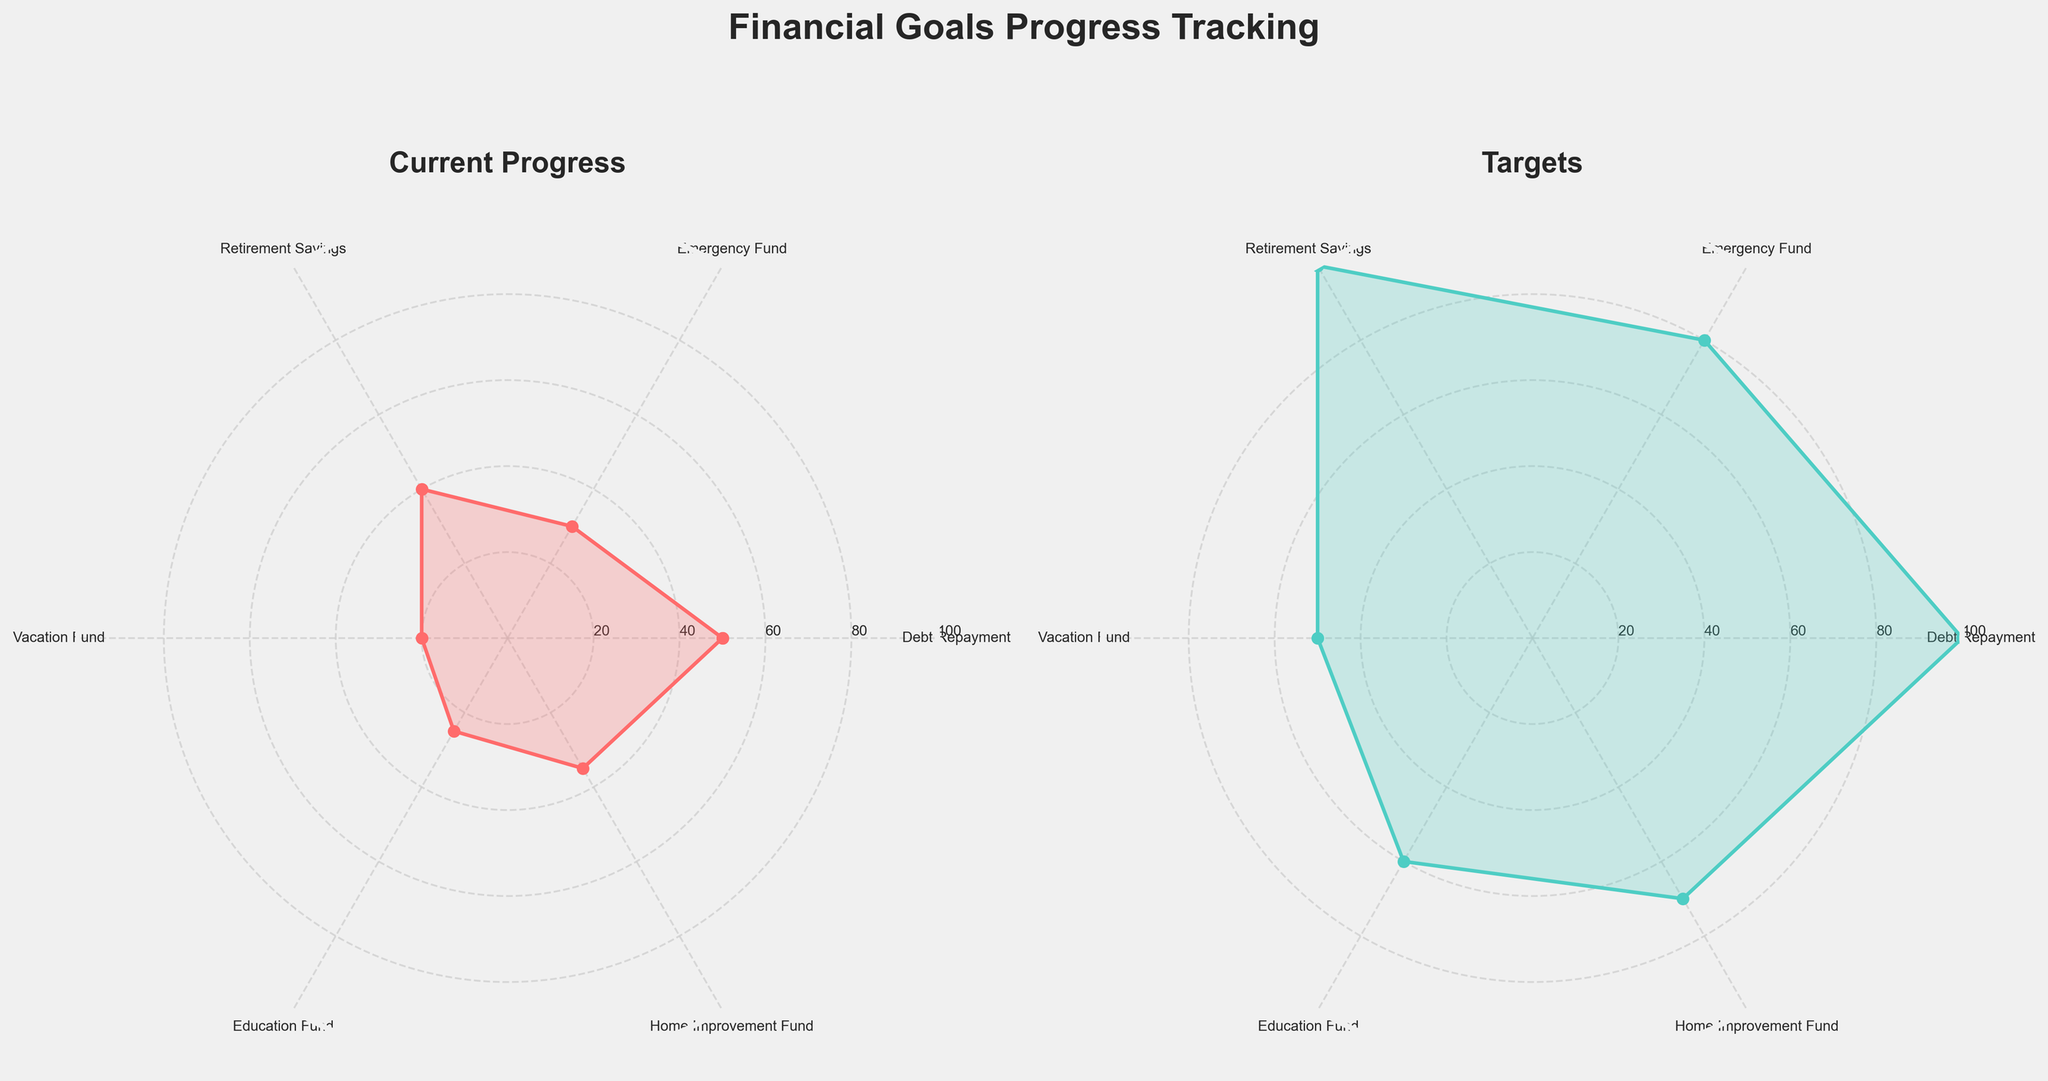How many financial categories are being tracked on the radar chart? To determine the number of financial categories, count the unique labels on the radar chart's axes. Each axis represents a different financial category.
Answer: 6 What are the categories with the highest and lowest current progress? To find this, look for the highest and lowest points on the Current Progress radar chart.
Answer: Debt Repayment and Vacation Fund What is the difference between the target and current progress for the Education Fund? Check the target and current progress points of the Education Fund on both charts, then subtract the current progress from the target.
Answer: 35 Is the current progress for the Retirement Savings closer to the target compared to the Emergency Fund? Compare the distances between the current progress and target points for the Retirement Savings and Emergency Fund categories. The one with the smaller gap is closer to its target.
Answer: Yes Which category has the smallest gap between its current progress and its target? Evaluate the difference between current progress and target for each category and identify the smallest gap.
Answer: Debt Repayment What are the average target values across all financial categories? Add all the target values together and then divide by the number of categories to find the average.
Answer: 76.67 How does the difference in progress between Emergency Fund and Home Improvement Fund compare? Calculate the differences between current progress and target for both Emergency Fund and Home Improvement Fund, then compare these differences.
Answer: Home Improvement Fund has a smaller difference In which category is the current progress halfway to the target? Identify which category's current progress is approximately half of its target value.
Answer: Debt Repayment What percentage of the target is the current progress in the Vacation Fund? Divide the current progress by the target for the Vacation Fund and then multiply by 100 to get the percentage.
Answer: 40% Between Debt Repayment and Home Improvement Fund, which has more remaining progress to meet its target? Calculate the remaining progress (target - current progress) for Debt Repayment and Home Improvement Fund, then compare the two.
Answer: Home Improvement Fund 